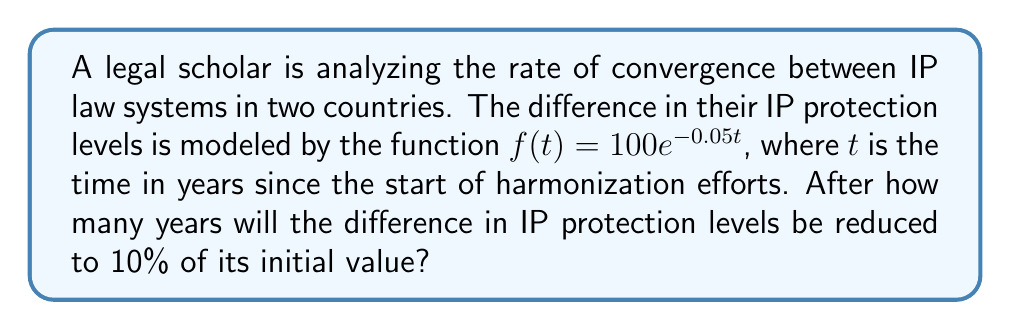Could you help me with this problem? To solve this problem, we need to follow these steps:

1) The initial difference (at $t=0$) is given by $f(0) = 100e^{-0.05(0)} = 100$.

2) We want to find when the difference is 10% of the initial value:
   $f(t) = 0.1 \times 100 = 10$

3) Let's set up the equation:
   $10 = 100e^{-0.05t}$

4) Divide both sides by 100:
   $0.1 = e^{-0.05t}$

5) Take the natural logarithm of both sides:
   $\ln(0.1) = -0.05t$

6) Solve for $t$:
   $t = \frac{\ln(0.1)}{-0.05}$

7) Calculate the value:
   $t = \frac{-2.30259}{-0.05} \approx 46.0518$

Therefore, it will take approximately 46.0518 years for the difference in IP protection levels to be reduced to 10% of its initial value.
Answer: $46.0518$ years 